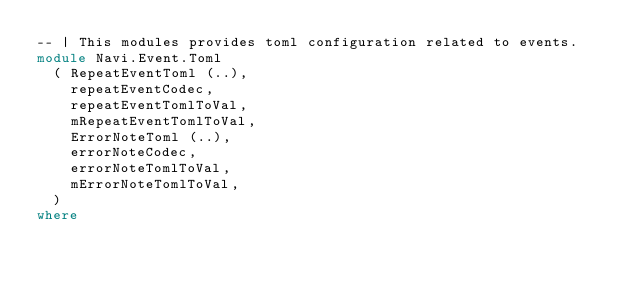Convert code to text. <code><loc_0><loc_0><loc_500><loc_500><_Haskell_>-- | This modules provides toml configuration related to events.
module Navi.Event.Toml
  ( RepeatEventToml (..),
    repeatEventCodec,
    repeatEventTomlToVal,
    mRepeatEventTomlToVal,
    ErrorNoteToml (..),
    errorNoteCodec,
    errorNoteTomlToVal,
    mErrorNoteTomlToVal,
  )
where
</code> 